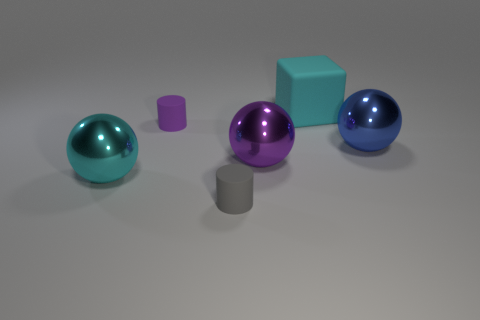Add 1 small gray things. How many objects exist? 7 Subtract all purple cylinders. How many cylinders are left? 1 Subtract 1 cylinders. How many cylinders are left? 1 Subtract all cylinders. How many objects are left? 4 Subtract all blue spheres. Subtract all tiny cylinders. How many objects are left? 3 Add 2 cyan balls. How many cyan balls are left? 3 Add 2 purple balls. How many purple balls exist? 3 Subtract 0 brown cylinders. How many objects are left? 6 Subtract all brown cubes. Subtract all green cylinders. How many cubes are left? 1 Subtract all gray cylinders. How many cyan spheres are left? 1 